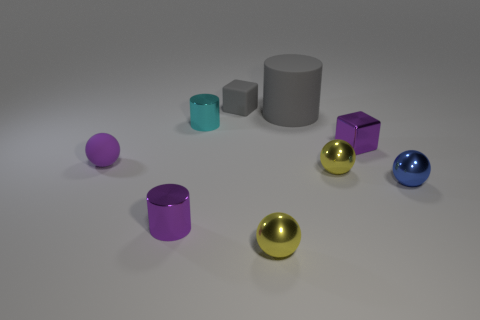If these objects were part of a collection, what might the theme of the collection be? This ensemble could represent a collection themed around 'Geometric Elegance', showcasing the beauty of simple geometric shapes rendered in various colors and metallic textures. It's a visual exploration of how primary shapes interact with light and color to create artful compositions. 